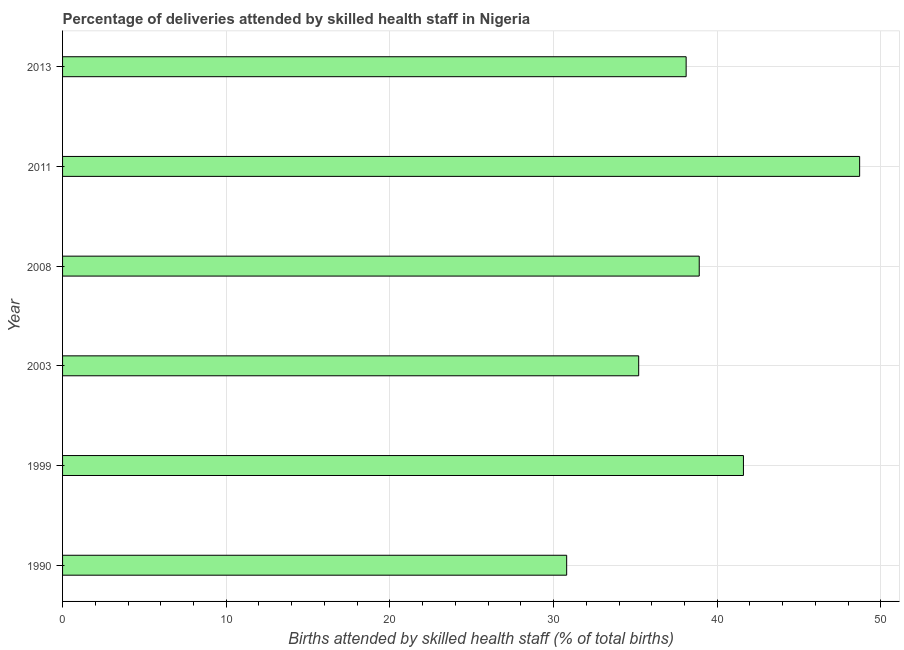Does the graph contain grids?
Offer a very short reply. Yes. What is the title of the graph?
Keep it short and to the point. Percentage of deliveries attended by skilled health staff in Nigeria. What is the label or title of the X-axis?
Your response must be concise. Births attended by skilled health staff (% of total births). What is the label or title of the Y-axis?
Your answer should be very brief. Year. What is the number of births attended by skilled health staff in 1990?
Your answer should be compact. 30.8. Across all years, what is the maximum number of births attended by skilled health staff?
Your answer should be compact. 48.7. Across all years, what is the minimum number of births attended by skilled health staff?
Keep it short and to the point. 30.8. What is the sum of the number of births attended by skilled health staff?
Ensure brevity in your answer.  233.3. What is the average number of births attended by skilled health staff per year?
Give a very brief answer. 38.88. What is the median number of births attended by skilled health staff?
Give a very brief answer. 38.5. What is the ratio of the number of births attended by skilled health staff in 2008 to that in 2011?
Keep it short and to the point. 0.8. Is the difference between the number of births attended by skilled health staff in 2011 and 2013 greater than the difference between any two years?
Offer a very short reply. No. Is the sum of the number of births attended by skilled health staff in 1990 and 2013 greater than the maximum number of births attended by skilled health staff across all years?
Ensure brevity in your answer.  Yes. What is the difference between the highest and the lowest number of births attended by skilled health staff?
Offer a very short reply. 17.9. In how many years, is the number of births attended by skilled health staff greater than the average number of births attended by skilled health staff taken over all years?
Keep it short and to the point. 3. How many bars are there?
Your response must be concise. 6. Are all the bars in the graph horizontal?
Offer a very short reply. Yes. How many years are there in the graph?
Offer a very short reply. 6. What is the difference between two consecutive major ticks on the X-axis?
Provide a succinct answer. 10. What is the Births attended by skilled health staff (% of total births) in 1990?
Keep it short and to the point. 30.8. What is the Births attended by skilled health staff (% of total births) of 1999?
Provide a succinct answer. 41.6. What is the Births attended by skilled health staff (% of total births) of 2003?
Make the answer very short. 35.2. What is the Births attended by skilled health staff (% of total births) in 2008?
Provide a succinct answer. 38.9. What is the Births attended by skilled health staff (% of total births) in 2011?
Ensure brevity in your answer.  48.7. What is the Births attended by skilled health staff (% of total births) of 2013?
Provide a short and direct response. 38.1. What is the difference between the Births attended by skilled health staff (% of total births) in 1990 and 2011?
Keep it short and to the point. -17.9. What is the difference between the Births attended by skilled health staff (% of total births) in 1999 and 2003?
Provide a succinct answer. 6.4. What is the difference between the Births attended by skilled health staff (% of total births) in 1999 and 2011?
Your response must be concise. -7.1. What is the difference between the Births attended by skilled health staff (% of total births) in 1999 and 2013?
Ensure brevity in your answer.  3.5. What is the difference between the Births attended by skilled health staff (% of total births) in 2003 and 2008?
Provide a succinct answer. -3.7. What is the difference between the Births attended by skilled health staff (% of total births) in 2003 and 2011?
Give a very brief answer. -13.5. What is the difference between the Births attended by skilled health staff (% of total births) in 2008 and 2011?
Ensure brevity in your answer.  -9.8. What is the difference between the Births attended by skilled health staff (% of total births) in 2008 and 2013?
Provide a short and direct response. 0.8. What is the ratio of the Births attended by skilled health staff (% of total births) in 1990 to that in 1999?
Provide a short and direct response. 0.74. What is the ratio of the Births attended by skilled health staff (% of total births) in 1990 to that in 2008?
Offer a terse response. 0.79. What is the ratio of the Births attended by skilled health staff (% of total births) in 1990 to that in 2011?
Provide a succinct answer. 0.63. What is the ratio of the Births attended by skilled health staff (% of total births) in 1990 to that in 2013?
Offer a very short reply. 0.81. What is the ratio of the Births attended by skilled health staff (% of total births) in 1999 to that in 2003?
Provide a short and direct response. 1.18. What is the ratio of the Births attended by skilled health staff (% of total births) in 1999 to that in 2008?
Make the answer very short. 1.07. What is the ratio of the Births attended by skilled health staff (% of total births) in 1999 to that in 2011?
Provide a succinct answer. 0.85. What is the ratio of the Births attended by skilled health staff (% of total births) in 1999 to that in 2013?
Give a very brief answer. 1.09. What is the ratio of the Births attended by skilled health staff (% of total births) in 2003 to that in 2008?
Give a very brief answer. 0.91. What is the ratio of the Births attended by skilled health staff (% of total births) in 2003 to that in 2011?
Provide a short and direct response. 0.72. What is the ratio of the Births attended by skilled health staff (% of total births) in 2003 to that in 2013?
Make the answer very short. 0.92. What is the ratio of the Births attended by skilled health staff (% of total births) in 2008 to that in 2011?
Give a very brief answer. 0.8. What is the ratio of the Births attended by skilled health staff (% of total births) in 2008 to that in 2013?
Make the answer very short. 1.02. What is the ratio of the Births attended by skilled health staff (% of total births) in 2011 to that in 2013?
Your answer should be compact. 1.28. 